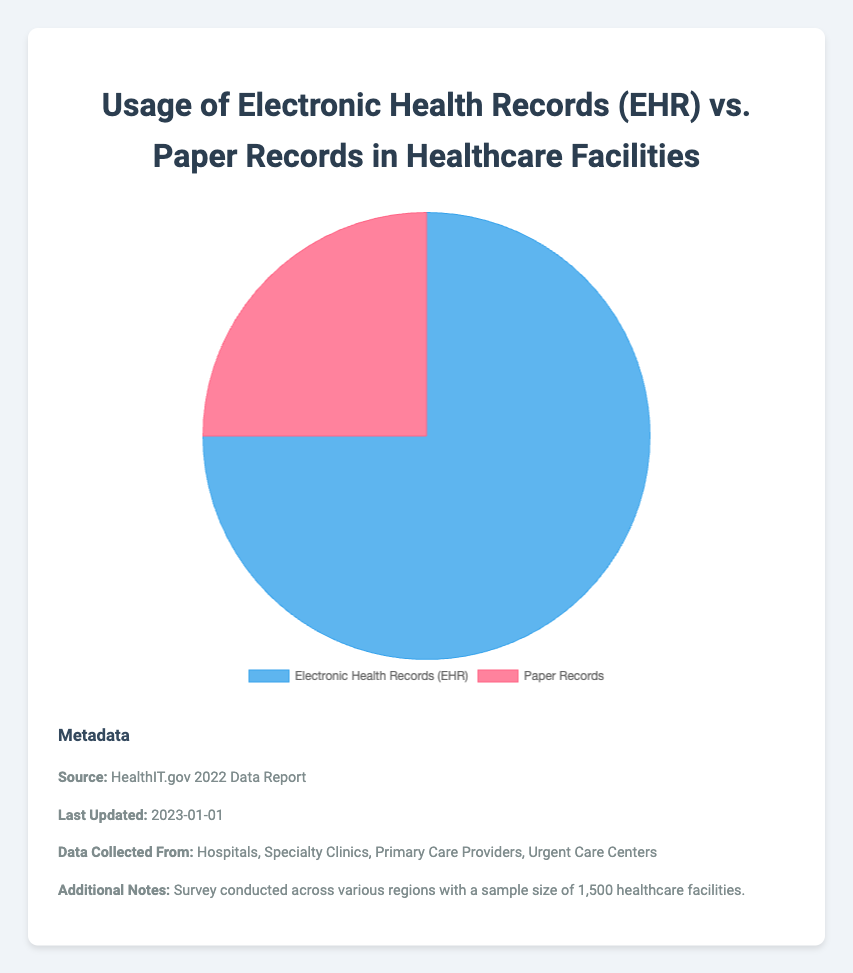What's the percentage of healthcare facilities that use EHR? The pie chart shows segments representing the usage of Electronic Health Records and Paper Records. The segment labeled "Electronic Health Records (EHR)" corresponds to 75%.
Answer: 75% What's the percentage difference between the usage of EHR and paper records? The segment for Electronic Health Records (EHR) is 75% and for Paper Records is 25%. The difference is calculated as 75% - 25% = 50%.
Answer: 50% Which type of record-keeping is more prevalent in healthcare facilities, EHR or paper records? By comparing the two segments of the pie chart, the segment for Electronic Health Records (EHR) is larger than the segment for Paper Records. Therefore, EHR is more prevalent.
Answer: EHR What percentage of healthcare facilities do not use EHR? The pie chart segments sum to 100%. Since 75% use Electronic Health Records (EHR), the remaining portion that does not use EHR is 100% - 75% = 25%.
Answer: 25% How many healthcare facilities were surveyed, given the sample size and percentage using EHR? According to the metadata, the sample size is 1,500 healthcare facilities. Knowing 75% of them use EHR means 75/100 * 1500 = 1,125 facilities use EHR.
Answer: 1,125 If 20 more facilities were surveyed and they all used paper records, what's the new percentage of facilities using paper records? Initially, 375 facilities used paper records (25% of 1,500). Adding 20 more makes it 395 out of 1,520. The new percentage is (395 / 1520) * 100 ≈ 25.99%.
Answer: 25.99% Visually, how can you distinguish the segment representing EHR from the one representing paper records? The segment representing Electronic Health Records (EHR) is shaded in blue, while the segment for Paper Records is shaded in red. The blue segment is also larger than the red segment.
Answer: Color and size What source provides the information for the data represented in the pie chart? According to the metadata below the chart, the source is the "HealthIT.gov 2022 Data Report."
Answer: HealthIT.gov 2022 Data Report 